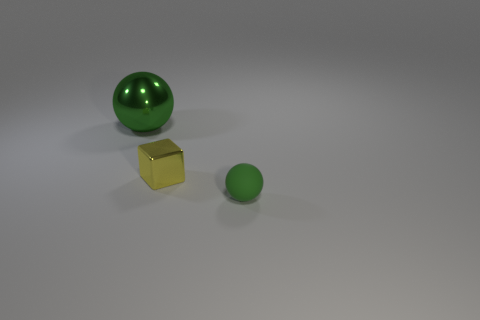What shape is the tiny object that is to the right of the small metal object?
Your answer should be compact. Sphere. Is the shape of the green thing that is behind the tiny sphere the same as  the tiny yellow object?
Make the answer very short. No. How many things are yellow shiny blocks on the right side of the big thing or shiny cubes?
Your response must be concise. 1. What is the color of the other thing that is the same shape as the large metallic object?
Your response must be concise. Green. Is there anything else of the same color as the rubber ball?
Give a very brief answer. Yes. There is a green sphere behind the tiny metal thing; how big is it?
Offer a terse response. Large. There is a metallic cube; is it the same color as the sphere in front of the large sphere?
Your answer should be very brief. No. How many other things are made of the same material as the small yellow cube?
Offer a very short reply. 1. Is the number of small brown matte things greater than the number of green objects?
Provide a succinct answer. No. Is the color of the tiny block in front of the green metal sphere the same as the big thing?
Provide a short and direct response. No. 